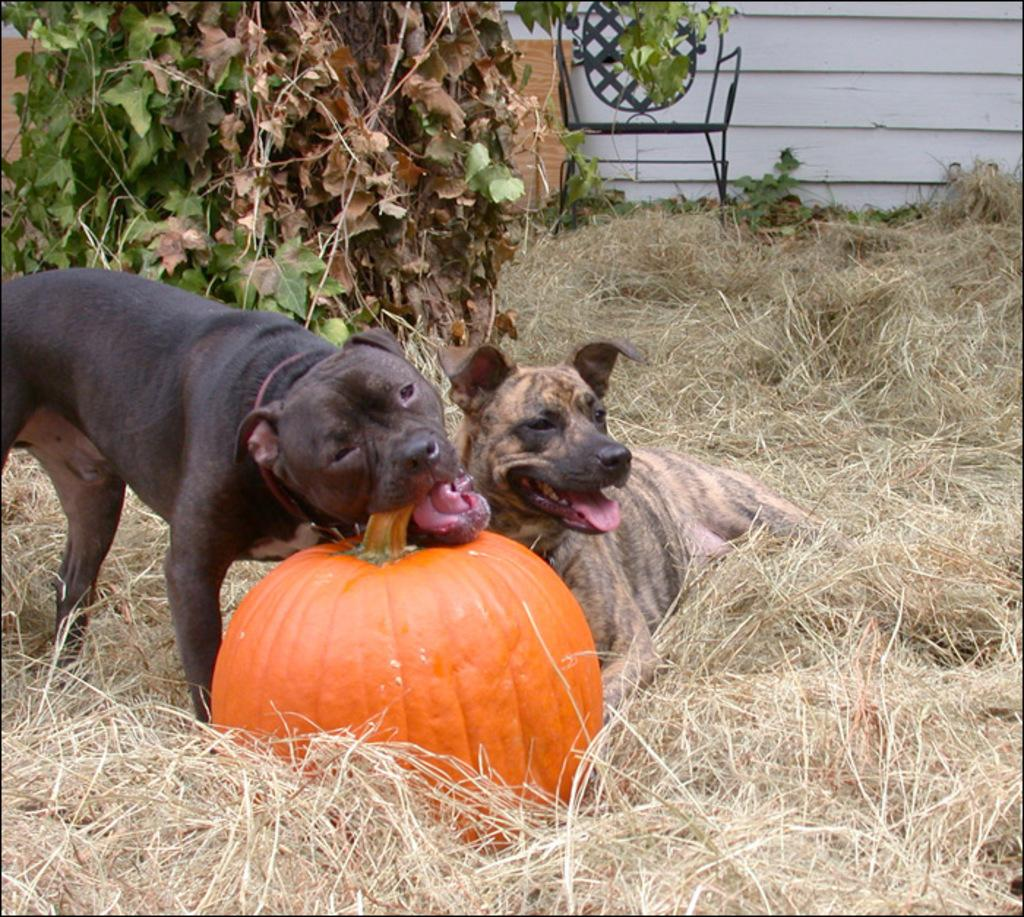How many dogs are in the image? There are two dogs in the image. What is the surface the dogs are standing on? The dogs are on dry grass. What is one of the dogs doing in the image? One dog is biting a pumpkin. What can be seen in the background of the image? There is a tree, a chair, a wooden plank, and a wall in the background of the image. What type of government is depicted in the image? There is no depiction of a government in the image; it features two dogs on dry grass, one of which is biting a pumpkin. How many flies can be seen in the image? There are no flies present in the image. 